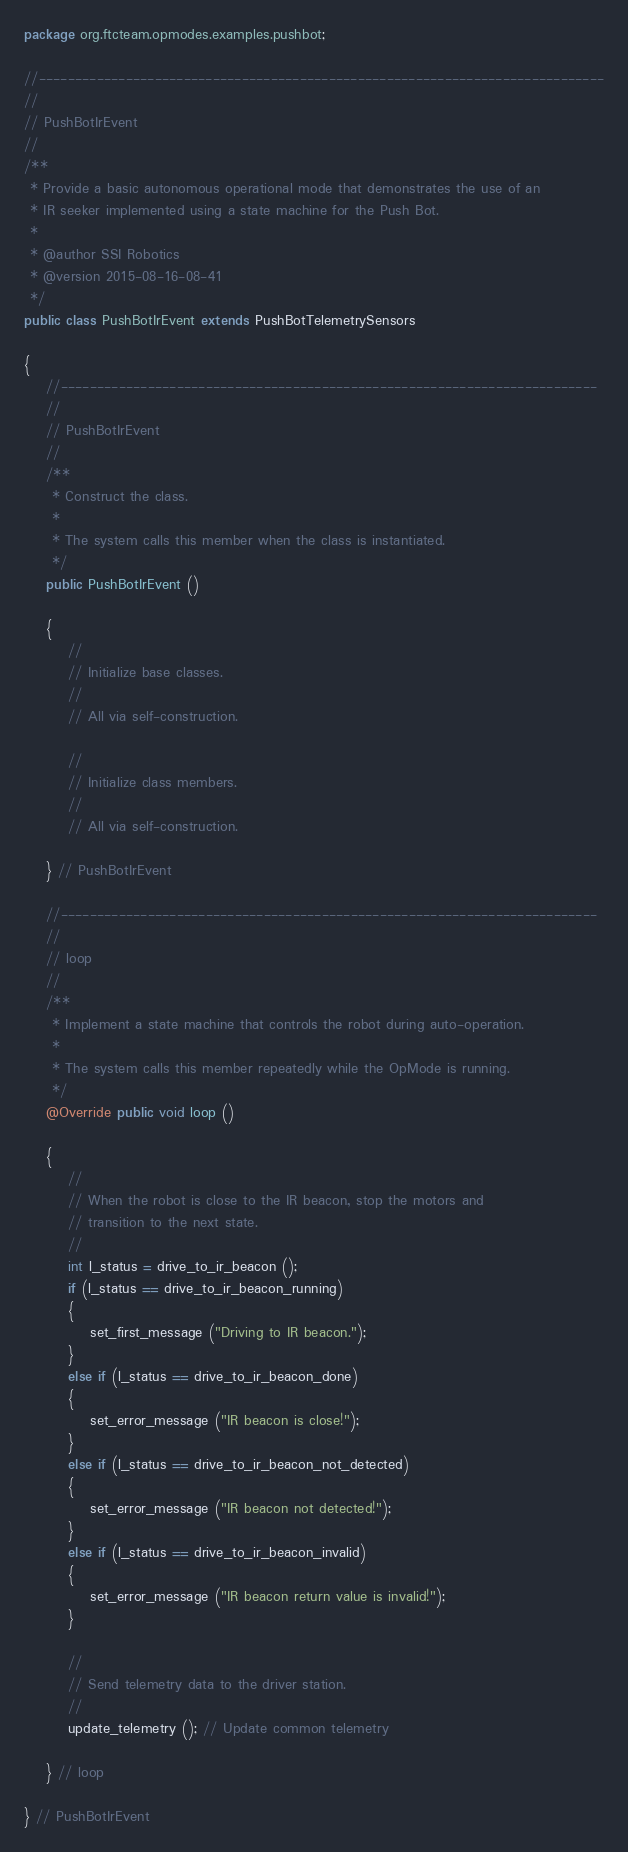<code> <loc_0><loc_0><loc_500><loc_500><_Java_>package org.ftcteam.opmodes.examples.pushbot;

//------------------------------------------------------------------------------
//
// PushBotIrEvent
//
/**
 * Provide a basic autonomous operational mode that demonstrates the use of an
 * IR seeker implemented using a state machine for the Push Bot.
 *
 * @author SSI Robotics
 * @version 2015-08-16-08-41
 */
public class PushBotIrEvent extends PushBotTelemetrySensors

{
    //--------------------------------------------------------------------------
    //
    // PushBotIrEvent
    //
    /**
     * Construct the class.
     *
     * The system calls this member when the class is instantiated.
     */
    public PushBotIrEvent ()

    {
        //
        // Initialize base classes.
        //
        // All via self-construction.

        //
        // Initialize class members.
        //
        // All via self-construction.

    } // PushBotIrEvent

    //--------------------------------------------------------------------------
    //
    // loop
    //
    /**
     * Implement a state machine that controls the robot during auto-operation.
     *
     * The system calls this member repeatedly while the OpMode is running.
     */
    @Override public void loop ()

    {
        //
        // When the robot is close to the IR beacon, stop the motors and
        // transition to the next state.
        //
        int l_status = drive_to_ir_beacon ();
        if (l_status == drive_to_ir_beacon_running)
        {
            set_first_message ("Driving to IR beacon.");
        }
        else if (l_status == drive_to_ir_beacon_done)
        {
            set_error_message ("IR beacon is close!");
        }
        else if (l_status == drive_to_ir_beacon_not_detected)
        {
            set_error_message ("IR beacon not detected!");
        }
        else if (l_status == drive_to_ir_beacon_invalid)
        {
            set_error_message ("IR beacon return value is invalid!");
        }

        //
        // Send telemetry data to the driver station.
        //
        update_telemetry (); // Update common telemetry

    } // loop

} // PushBotIrEvent
</code> 